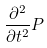Convert formula to latex. <formula><loc_0><loc_0><loc_500><loc_500>\frac { \partial ^ { 2 } } { \partial t ^ { 2 } } P</formula> 